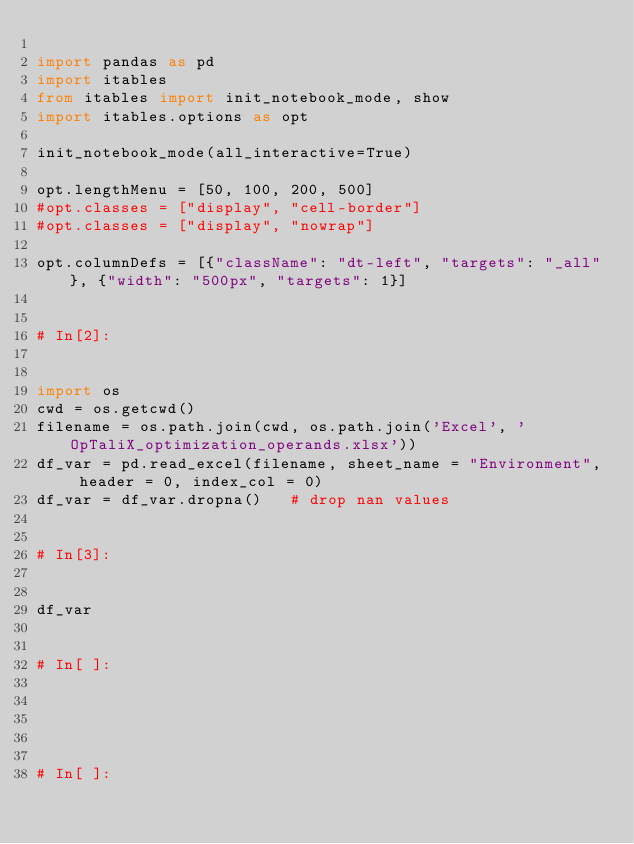<code> <loc_0><loc_0><loc_500><loc_500><_Python_>
import pandas as pd
import itables
from itables import init_notebook_mode, show
import itables.options as opt

init_notebook_mode(all_interactive=True)

opt.lengthMenu = [50, 100, 200, 500]
#opt.classes = ["display", "cell-border"]
#opt.classes = ["display", "nowrap"]

opt.columnDefs = [{"className": "dt-left", "targets": "_all"}, {"width": "500px", "targets": 1}]


# In[2]:


import os
cwd = os.getcwd()
filename = os.path.join(cwd, os.path.join('Excel', 'OpTaliX_optimization_operands.xlsx'))
df_var = pd.read_excel(filename, sheet_name = "Environment", header = 0, index_col = 0)
df_var = df_var.dropna()   # drop nan values


# In[3]:


df_var


# In[ ]:





# In[ ]:




</code> 